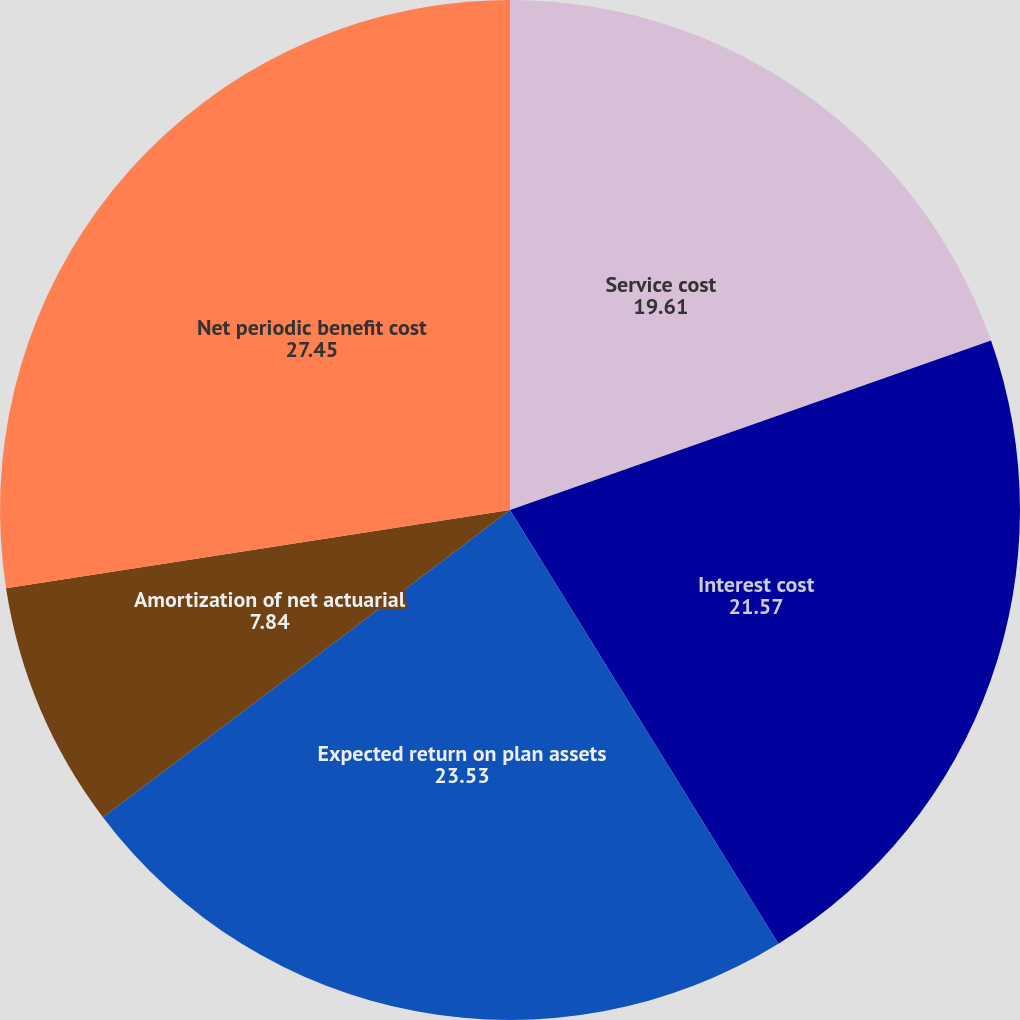<chart> <loc_0><loc_0><loc_500><loc_500><pie_chart><fcel>Service cost<fcel>Interest cost<fcel>Expected return on plan assets<fcel>Amortization of net actuarial<fcel>Net periodic benefit cost<nl><fcel>19.61%<fcel>21.57%<fcel>23.53%<fcel>7.84%<fcel>27.45%<nl></chart> 